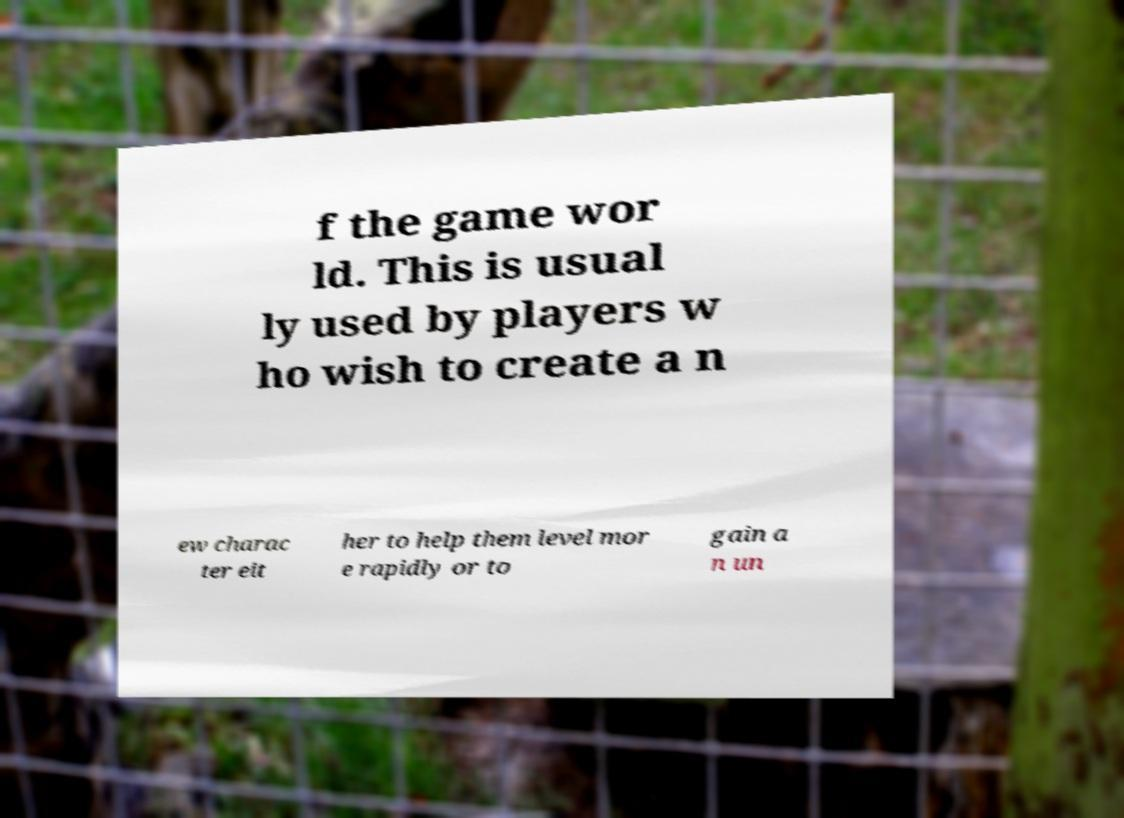There's text embedded in this image that I need extracted. Can you transcribe it verbatim? f the game wor ld. This is usual ly used by players w ho wish to create a n ew charac ter eit her to help them level mor e rapidly or to gain a n un 